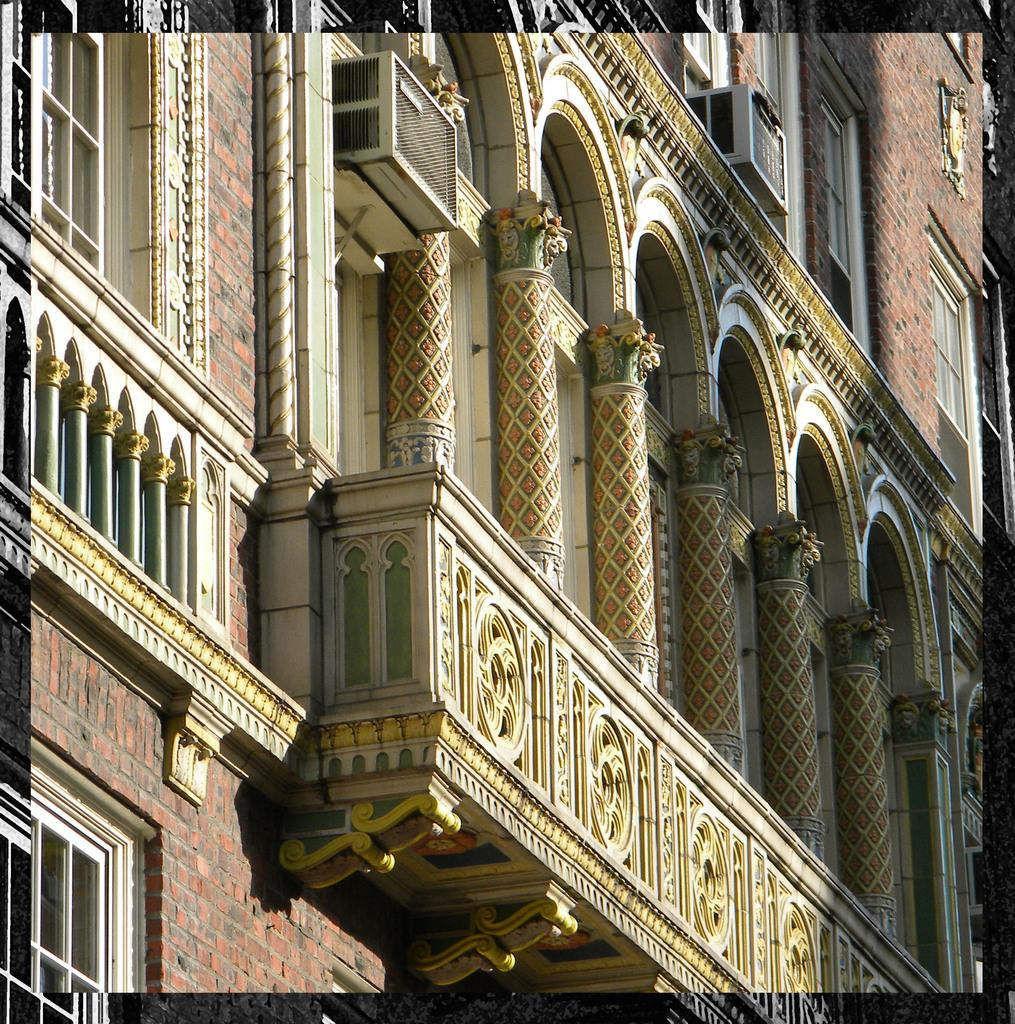What is the main subject of the image? The main subject of the image is a frame. What is inside the frame? The frame contains a building. What is the building made of? The building has a brick wall. What type of windows does the building have? The building has glass windows. What architectural features can be seen on the building? The building has pillars. What is used for cooling the building? The building has air conditioners. What type of stocking can be seen hanging in the alley near the building? There is no stocking or alley present in the image; it only features a frame with a building inside. 